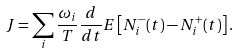Convert formula to latex. <formula><loc_0><loc_0><loc_500><loc_500>J = \sum _ { i } \frac { \omega _ { i } } { T } \frac { d } { d t } { E } \left [ N ^ { - } _ { i } ( t ) - N ^ { + } _ { i } ( t ) \right ] .</formula> 